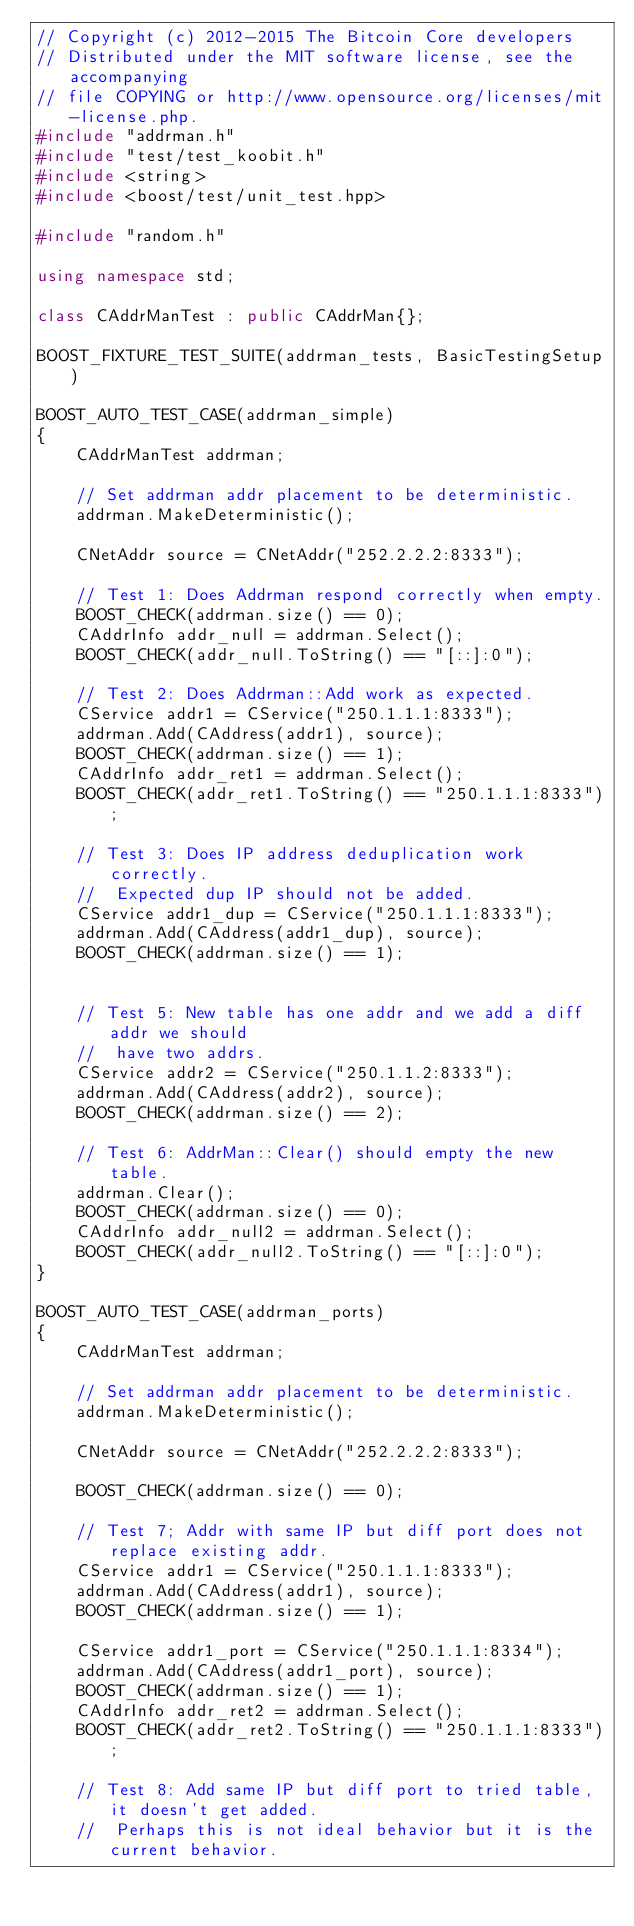<code> <loc_0><loc_0><loc_500><loc_500><_C++_>// Copyright (c) 2012-2015 The Bitcoin Core developers
// Distributed under the MIT software license, see the accompanying
// file COPYING or http://www.opensource.org/licenses/mit-license.php.
#include "addrman.h"
#include "test/test_koobit.h"
#include <string>
#include <boost/test/unit_test.hpp>

#include "random.h"

using namespace std;

class CAddrManTest : public CAddrMan{};

BOOST_FIXTURE_TEST_SUITE(addrman_tests, BasicTestingSetup)

BOOST_AUTO_TEST_CASE(addrman_simple)
{
    CAddrManTest addrman;

    // Set addrman addr placement to be deterministic.
    addrman.MakeDeterministic();

    CNetAddr source = CNetAddr("252.2.2.2:8333");

    // Test 1: Does Addrman respond correctly when empty.
    BOOST_CHECK(addrman.size() == 0);
    CAddrInfo addr_null = addrman.Select();
    BOOST_CHECK(addr_null.ToString() == "[::]:0");

    // Test 2: Does Addrman::Add work as expected.
    CService addr1 = CService("250.1.1.1:8333");
    addrman.Add(CAddress(addr1), source);
    BOOST_CHECK(addrman.size() == 1);
    CAddrInfo addr_ret1 = addrman.Select();
    BOOST_CHECK(addr_ret1.ToString() == "250.1.1.1:8333");

    // Test 3: Does IP address deduplication work correctly. 
    //  Expected dup IP should not be added.
    CService addr1_dup = CService("250.1.1.1:8333");
    addrman.Add(CAddress(addr1_dup), source);
    BOOST_CHECK(addrman.size() == 1);


    // Test 5: New table has one addr and we add a diff addr we should
    //  have two addrs.
    CService addr2 = CService("250.1.1.2:8333");
    addrman.Add(CAddress(addr2), source);
    BOOST_CHECK(addrman.size() == 2);

    // Test 6: AddrMan::Clear() should empty the new table. 
    addrman.Clear();
    BOOST_CHECK(addrman.size() == 0);
    CAddrInfo addr_null2 = addrman.Select();
    BOOST_CHECK(addr_null2.ToString() == "[::]:0");
}

BOOST_AUTO_TEST_CASE(addrman_ports)
{
    CAddrManTest addrman;

    // Set addrman addr placement to be deterministic.
    addrman.MakeDeterministic();

    CNetAddr source = CNetAddr("252.2.2.2:8333");

    BOOST_CHECK(addrman.size() == 0);

    // Test 7; Addr with same IP but diff port does not replace existing addr.
    CService addr1 = CService("250.1.1.1:8333");
    addrman.Add(CAddress(addr1), source);
    BOOST_CHECK(addrman.size() == 1);

    CService addr1_port = CService("250.1.1.1:8334");
    addrman.Add(CAddress(addr1_port), source);
    BOOST_CHECK(addrman.size() == 1);
    CAddrInfo addr_ret2 = addrman.Select();
    BOOST_CHECK(addr_ret2.ToString() == "250.1.1.1:8333");

    // Test 8: Add same IP but diff port to tried table, it doesn't get added.
    //  Perhaps this is not ideal behavior but it is the current behavior.</code> 